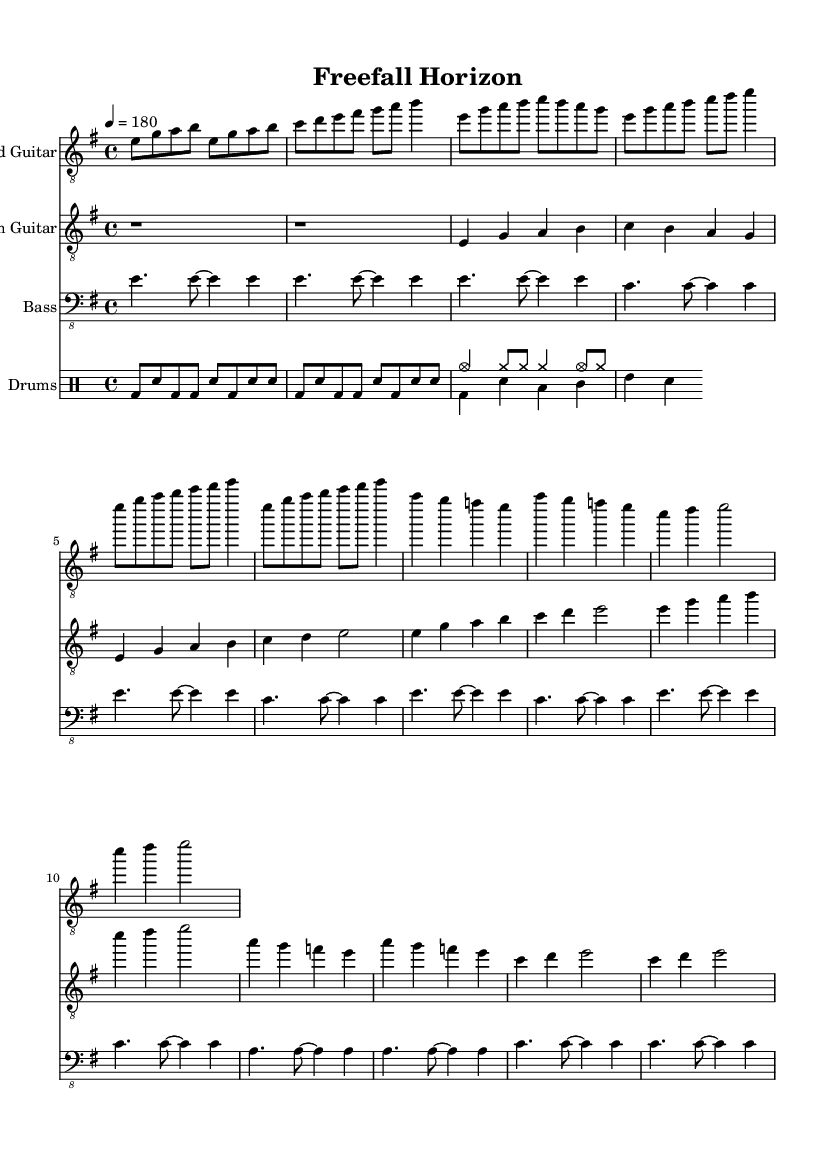What is the key signature of this music? The key signature is indicated at the beginning of the sheet music, showing that there are no sharps or flats, which means it is in E minor.
Answer: E minor What is the time signature of this music? The time signature is displayed at the beginning of the sheet music, indicating that there are four beats per measure, which is represented as 4/4.
Answer: 4/4 What is the tempo marking for this piece? The tempo marking, located at the beginning of the music, indicates a tempo of 180 beats per minute, noted as "4 = 180."
Answer: 180 How many sections are in the piece? By analyzing the structure of the sheet music, we see the distinct parts labeled as Intro, Verse, Chorus, and Bridge, leading to a total of four sections.
Answer: Four What is the main rhythm pattern used in the drums? The drum part features a basic pattern with bass drums and snare notes prominently repeated, showing a fast-paced rhythm typical in metal music.
Answer: Fast-paced What is the highest note in the lead guitar part? By examining the lead guitar part, the highest note occurs toward the end, where it reaches B in the third octave, indicating a high pitch.
Answer: B Which musical feature characterizes the melodic death metal genre reflected in this piece? The piece is characterized by melodic riffs and aggressive rhythms, combined with elements like harmonized guitar lines and complex drumming arrangements, which are core to the melodic death metal genre.
Answer: Melodic riffs 